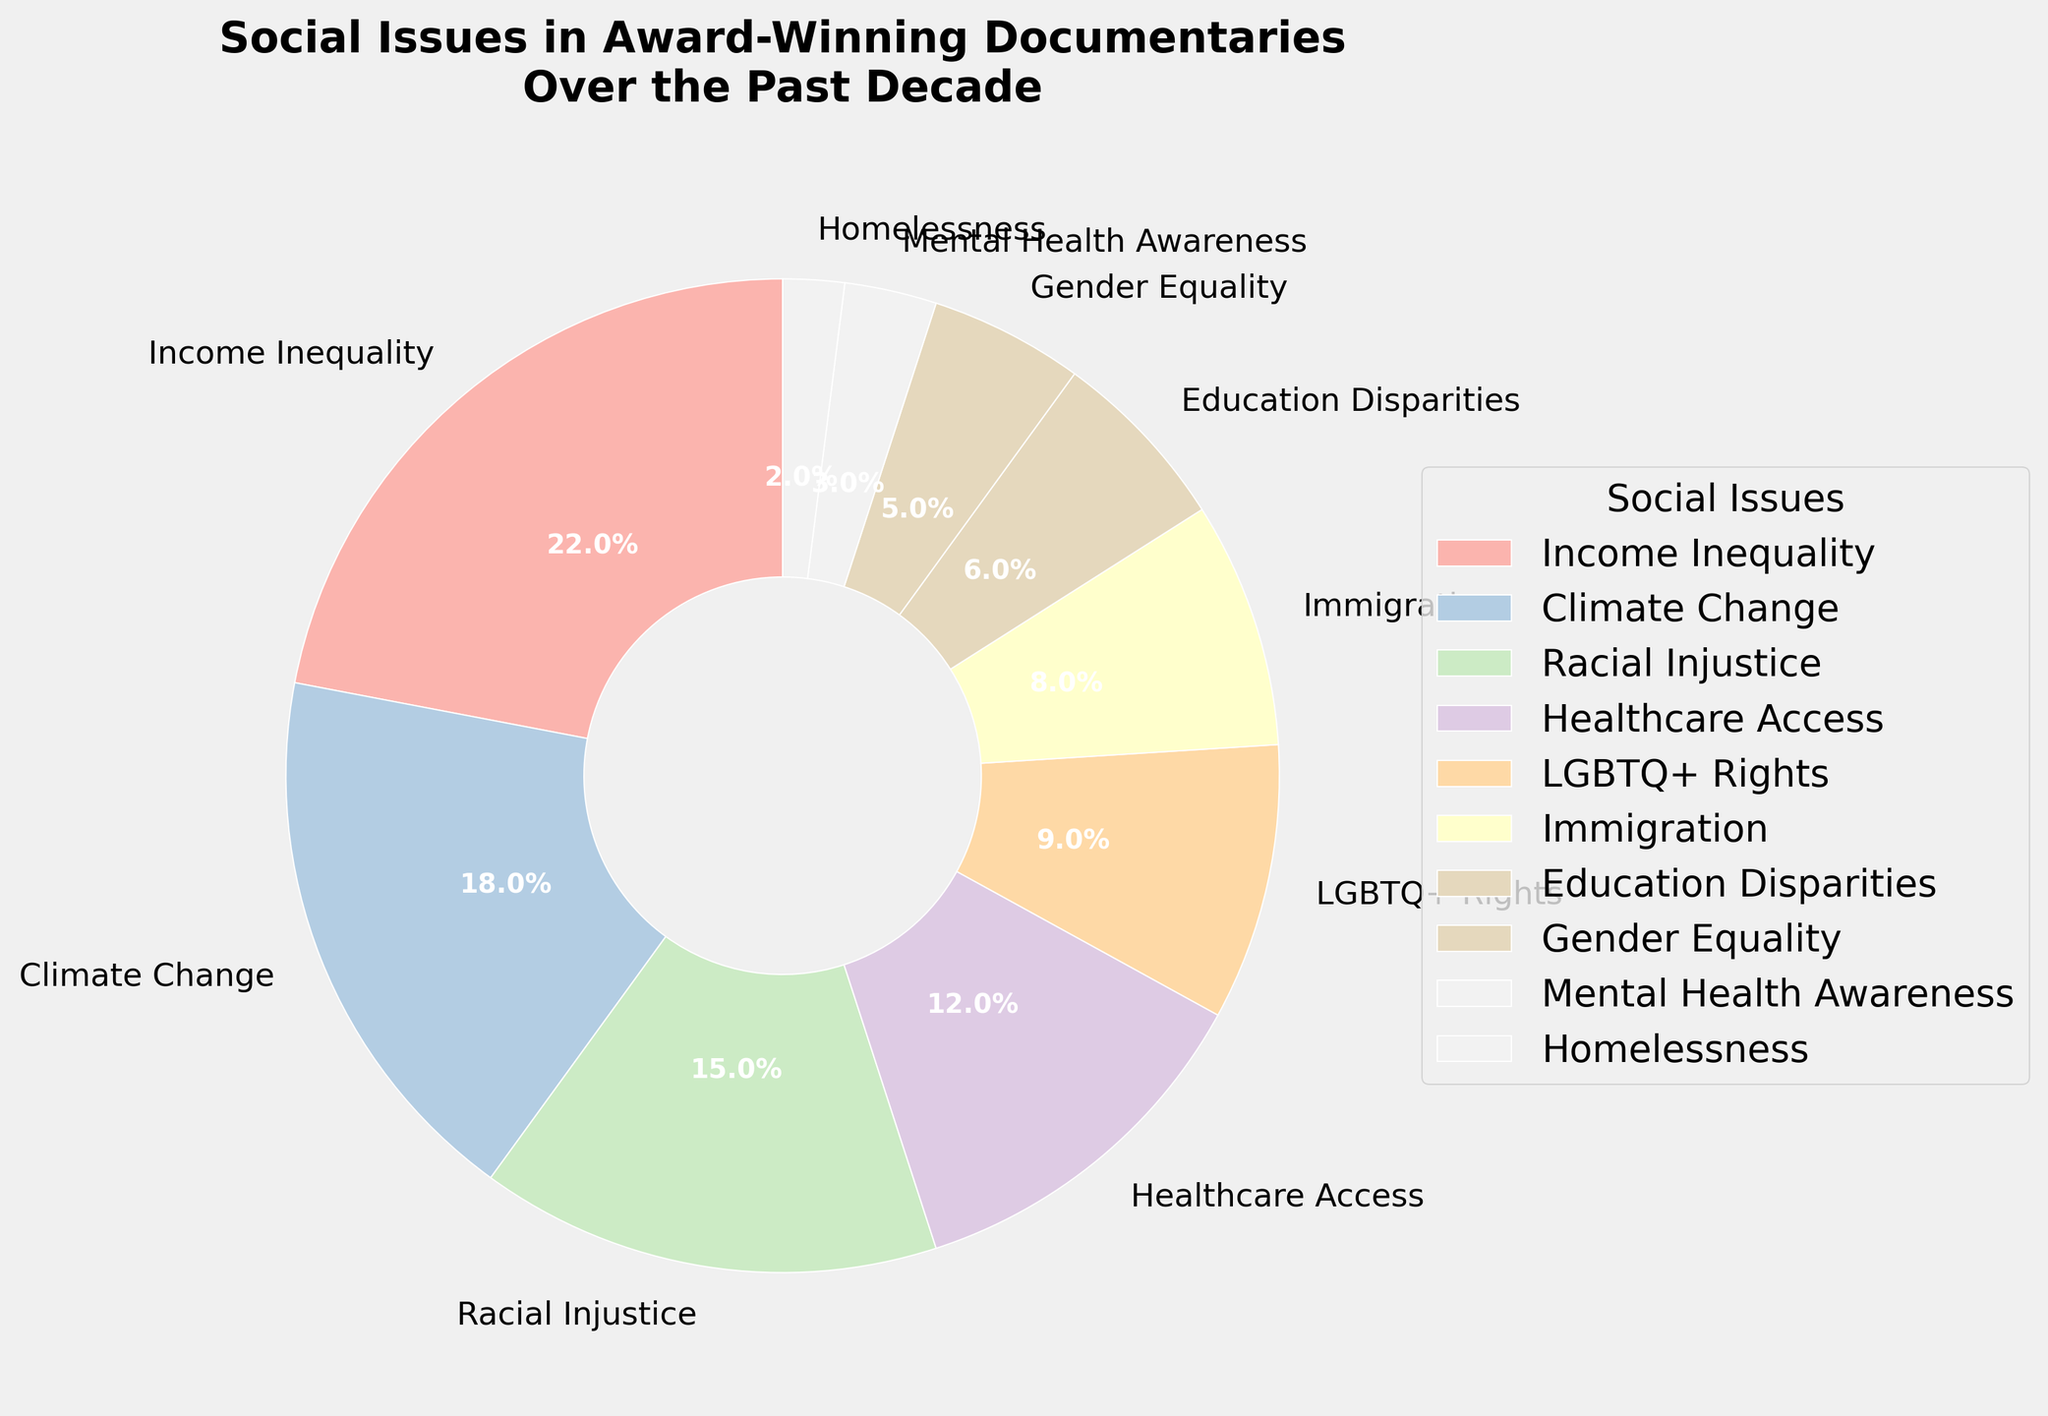What percentage of documentaries addressed both Climate Change and Racial Injustice combined? First, find the percentages for Climate Change (18%) and Racial Injustice (15%). Add these two values together: 18% + 15% = 33%.
Answer: 33% Which social issue is addressed the least frequently? Look at the percentage values for each topic. The smallest percentage is 2%, which corresponds to Homelessness.
Answer: Homelessness Are there more documentaries addressing Income Inequality or LGBTQ+ Rights? Compare the percentages of Income Inequality (22%) and LGBTQ+ Rights (9%). Since 22% is greater than 9%, more documentaries address Income Inequality.
Answer: Income Inequality What's the difference in percentage between Healthcare Access and Education Disparities? Identify the percentage for Healthcare Access (12%) and Education Disparities (6%). Subtract the smaller percentage from the larger one: 12% - 6% = 6%.
Answer: 6% What's the average percentage of documentaries addressing Gender Equality and Mental Health Awareness combined? Find the percentages for Gender Equality (5%) and Mental Health Awareness (3%). Add the two percentages: 5% + 3% = 8%. Then divide by 2 to find the average: 8% / 2 = 4%.
Answer: 4% How many social issues have a percentage of 10% or higher? List the topics with percentages 10% or higher: Income Inequality (22%), Climate Change (18%), Racial Injustice (15%), Healthcare Access (12%). There are 4 such topics.
Answer: 4 Is the total percentage of documentaries addressing Immigration and Homelessness greater than the percentage addressing Climate Change alone? Add the percentages for Immigration (8%) and Homelessness (2%): 8% + 2% = 10%. Compare with Climate Change (18%). Since 10% is less than 18%, the total is not greater.
Answer: No Which social issue takes up the largest segment in the pie chart? Identify the issue with the highest percentage value, which is Income Inequality at 22%.
Answer: Income Inequality What is the combined percentage of documentaries addressing LGBTQ+ Rights, Immigration, and Gender Equality? Add the percentages for LGBTQ+ Rights (9%), Immigration (8%), and Gender Equality (5%): 9% + 8% + 5% = 22%.
Answer: 22% 